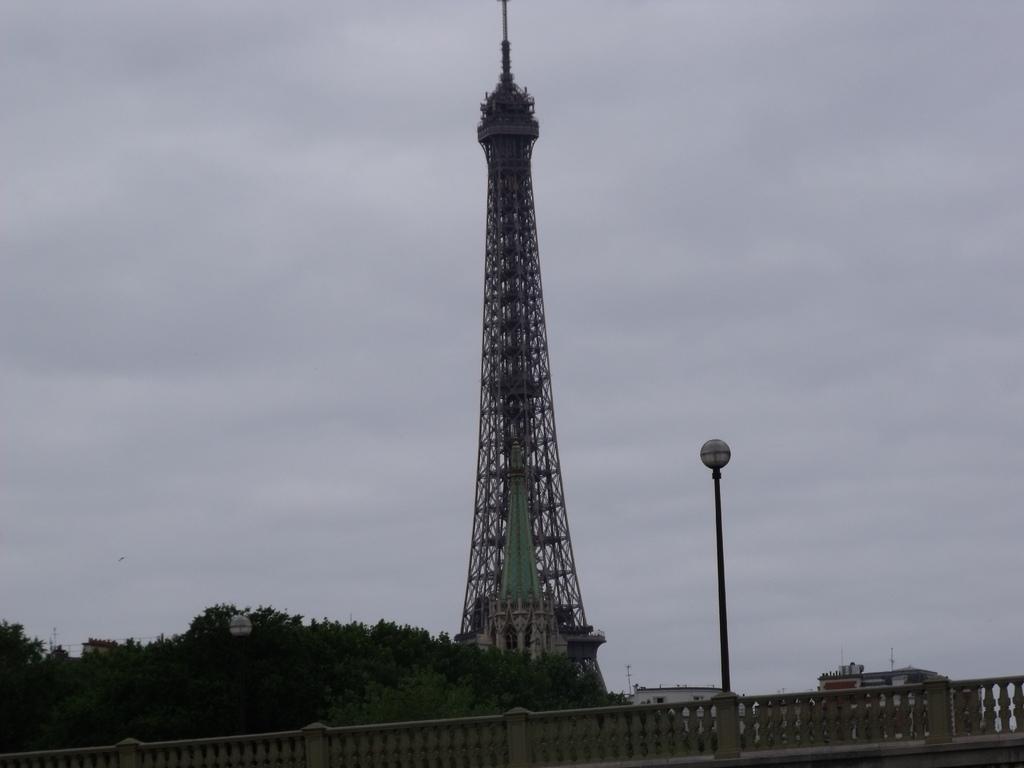In one or two sentences, can you explain what this image depicts? In the center of the image, we can see a tower and in the background, there are buildings, trees and we can see a pole and a bridge. 